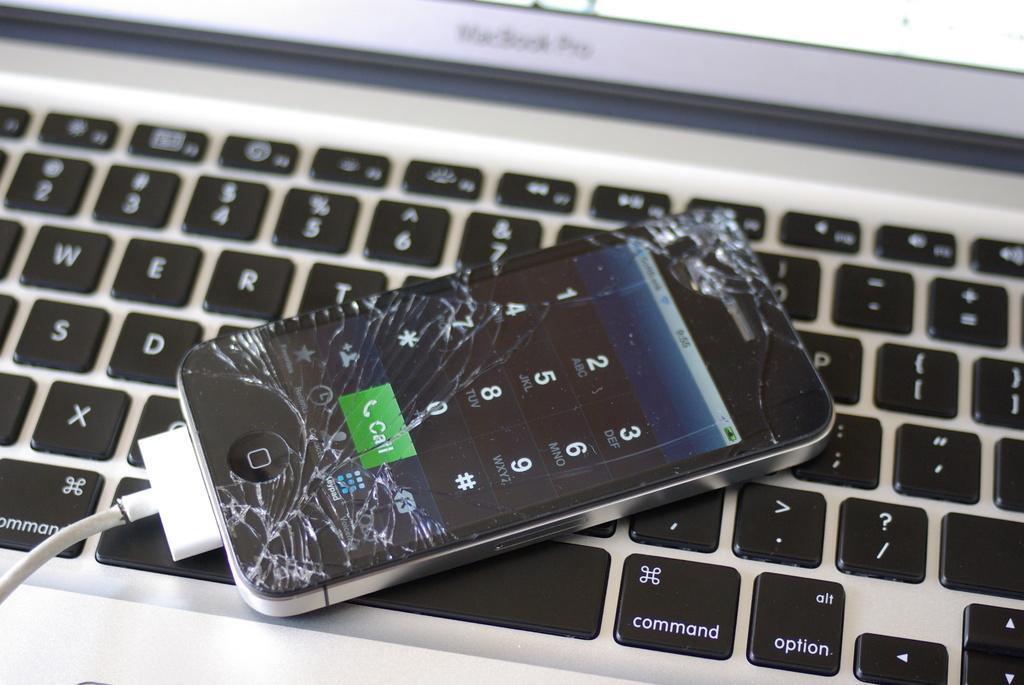<image>
Share a concise interpretation of the image provided. A smart phone with a badly cracked screen currently displaying a dialer and the call button. 